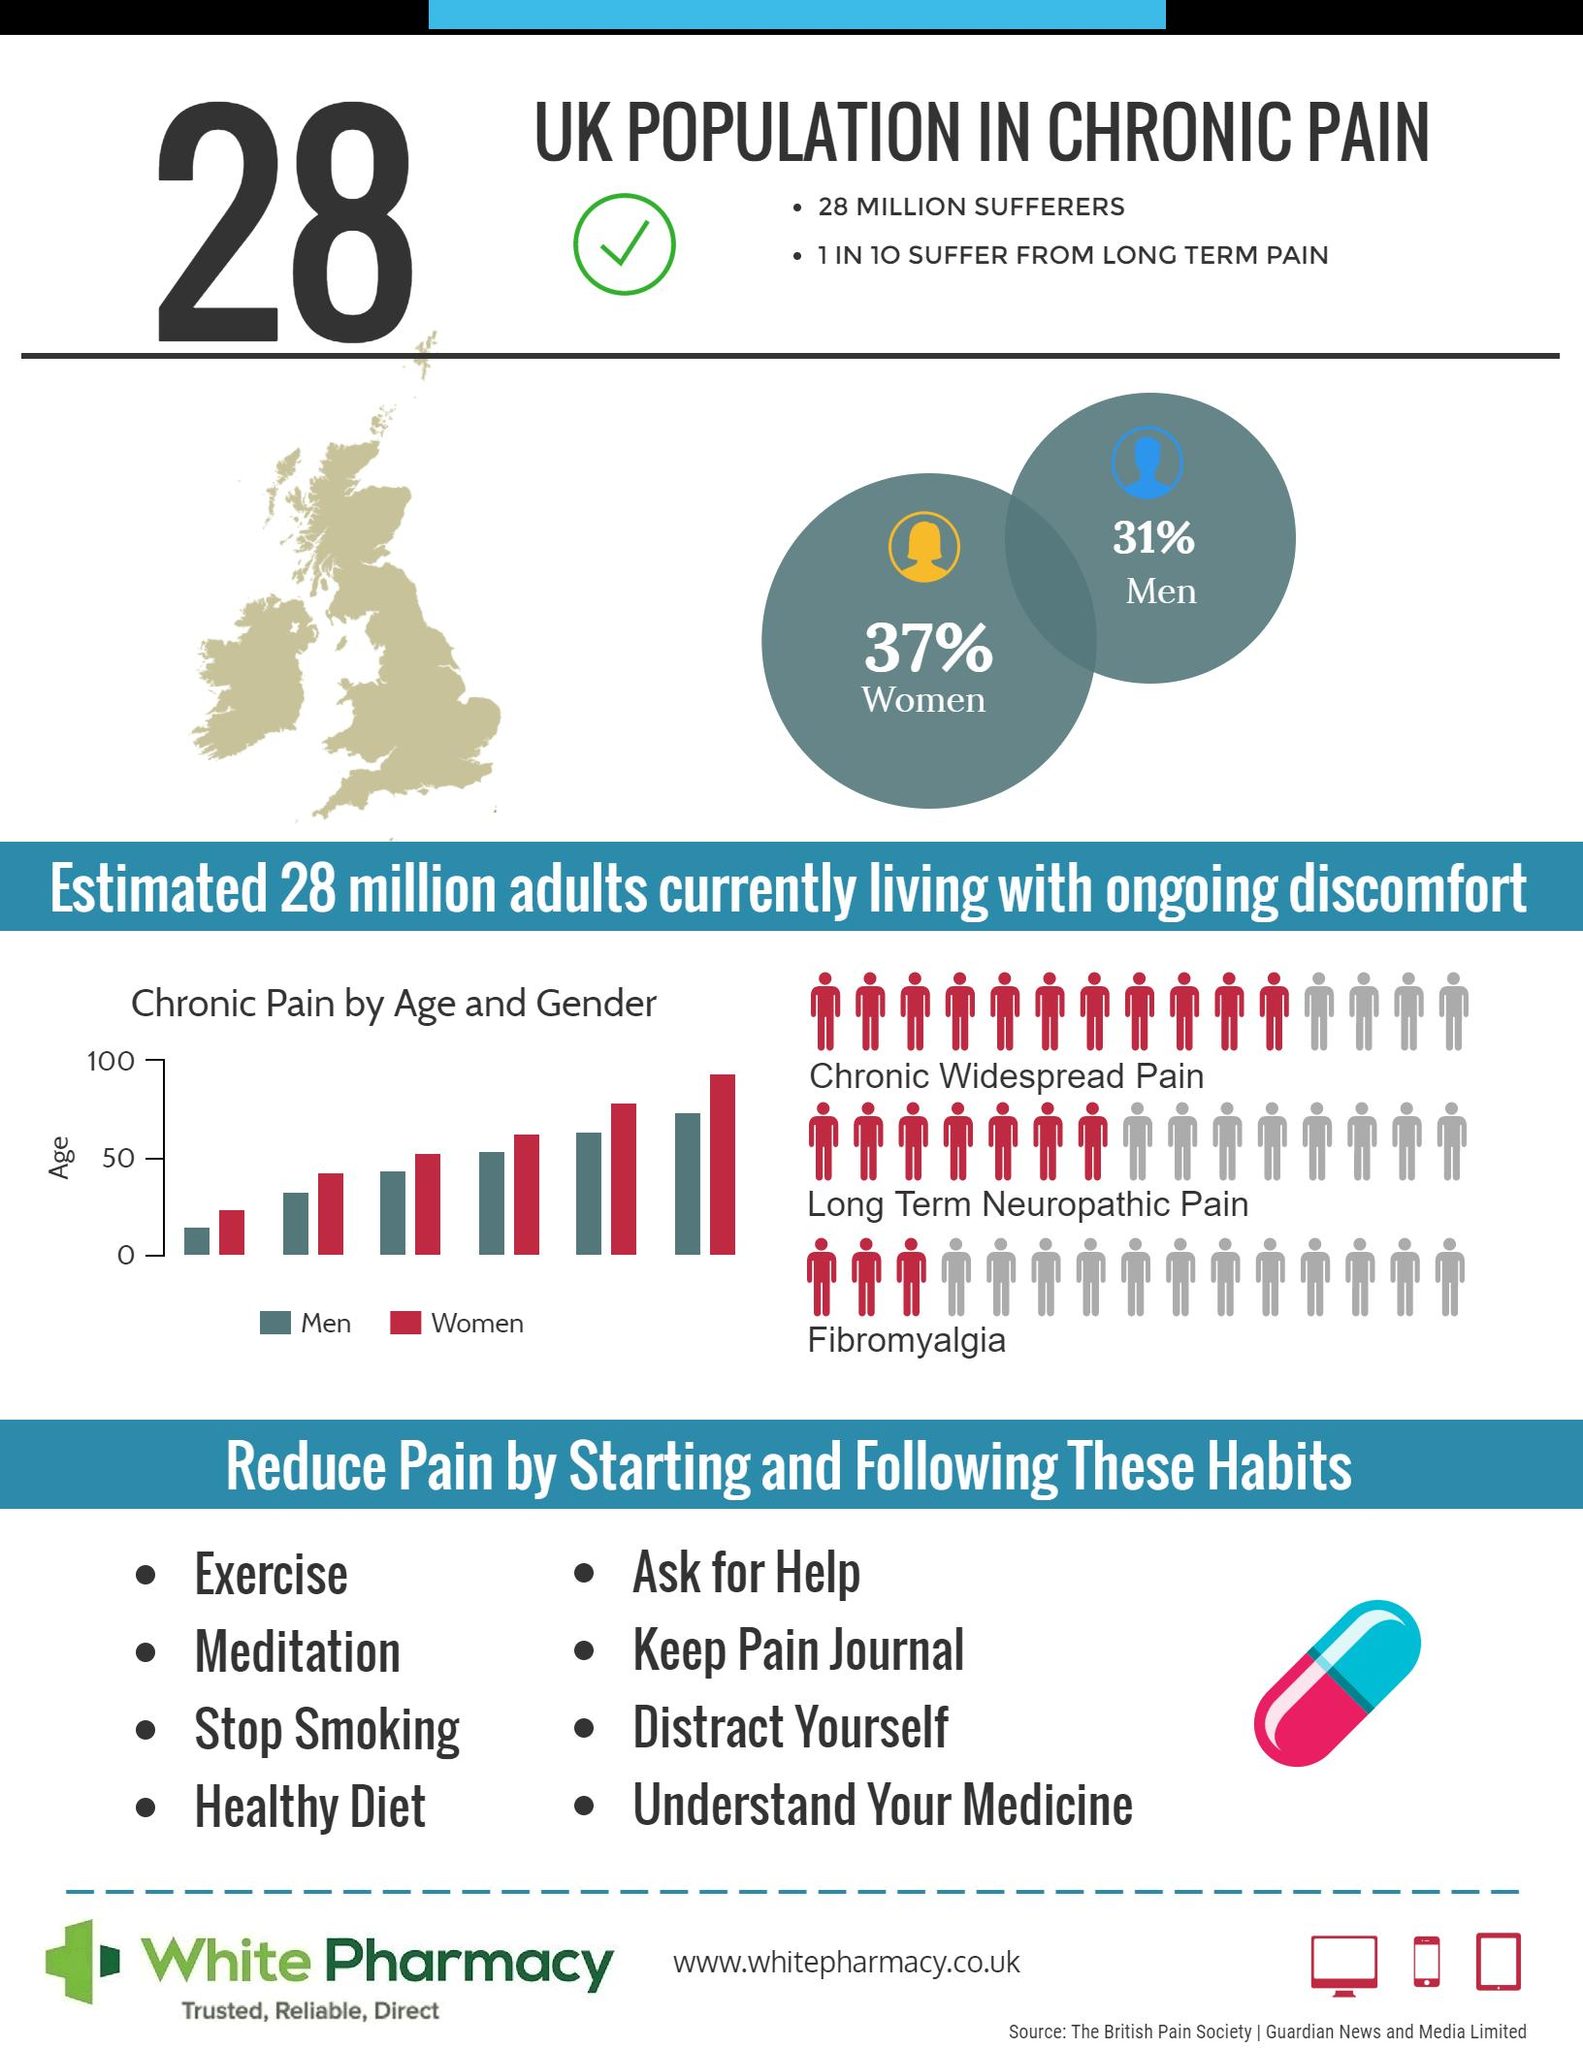Mention a couple of crucial points in this snapshot. According to a recent study, approximately 31% of men in the UK suffer from chronic pain. It is estimated that approximately 28 million people in the United Kingdom suffer from chronic pain. According to recent statistics, 37% of women in the UK suffer from chronic pain. 